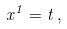<formula> <loc_0><loc_0><loc_500><loc_500>x ^ { 1 } = t \, ,</formula> 